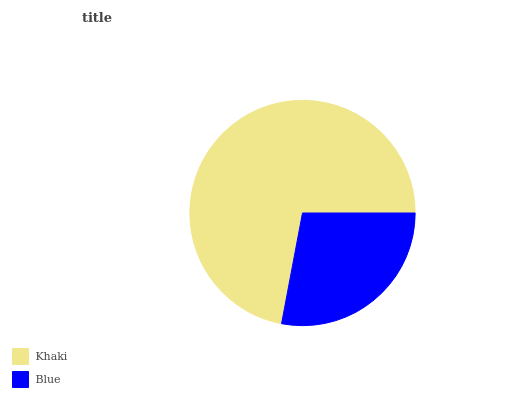Is Blue the minimum?
Answer yes or no. Yes. Is Khaki the maximum?
Answer yes or no. Yes. Is Blue the maximum?
Answer yes or no. No. Is Khaki greater than Blue?
Answer yes or no. Yes. Is Blue less than Khaki?
Answer yes or no. Yes. Is Blue greater than Khaki?
Answer yes or no. No. Is Khaki less than Blue?
Answer yes or no. No. Is Khaki the high median?
Answer yes or no. Yes. Is Blue the low median?
Answer yes or no. Yes. Is Blue the high median?
Answer yes or no. No. Is Khaki the low median?
Answer yes or no. No. 